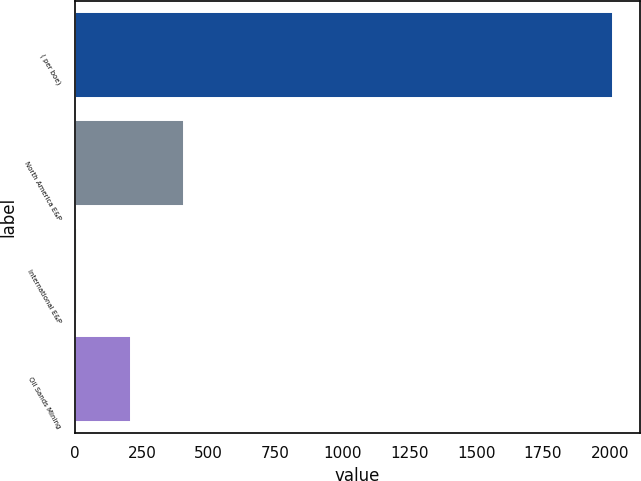Convert chart. <chart><loc_0><loc_0><loc_500><loc_500><bar_chart><fcel>( per boe)<fcel>North America E&P<fcel>International E&P<fcel>Oil Sands Mining<nl><fcel>2012<fcel>408.86<fcel>8.08<fcel>208.47<nl></chart> 